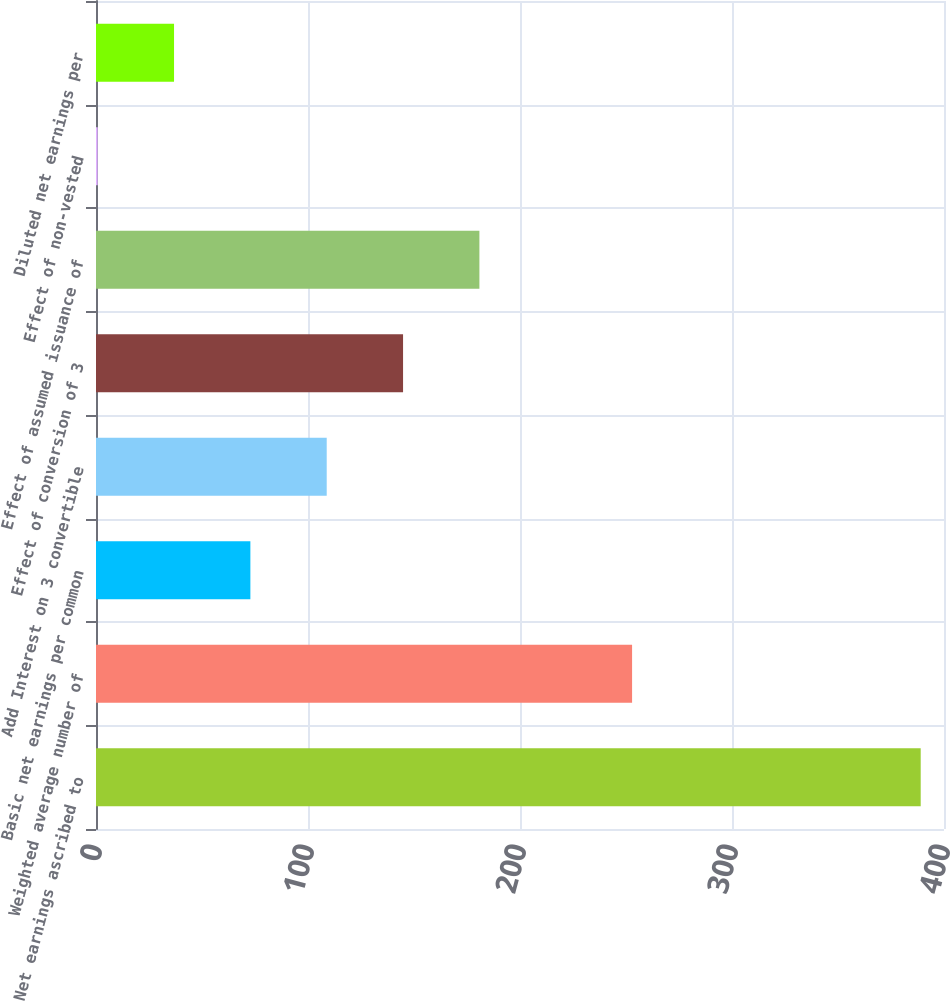<chart> <loc_0><loc_0><loc_500><loc_500><bar_chart><fcel>Net earnings ascribed to<fcel>Weighted average number of<fcel>Basic net earnings per common<fcel>Add Interest on 3 convertible<fcel>Effect of conversion of 3<fcel>Effect of assumed issuance of<fcel>Effect of non-vested<fcel>Diluted net earnings per<nl><fcel>389.01<fcel>252.87<fcel>72.82<fcel>108.83<fcel>144.84<fcel>180.85<fcel>0.8<fcel>36.81<nl></chart> 